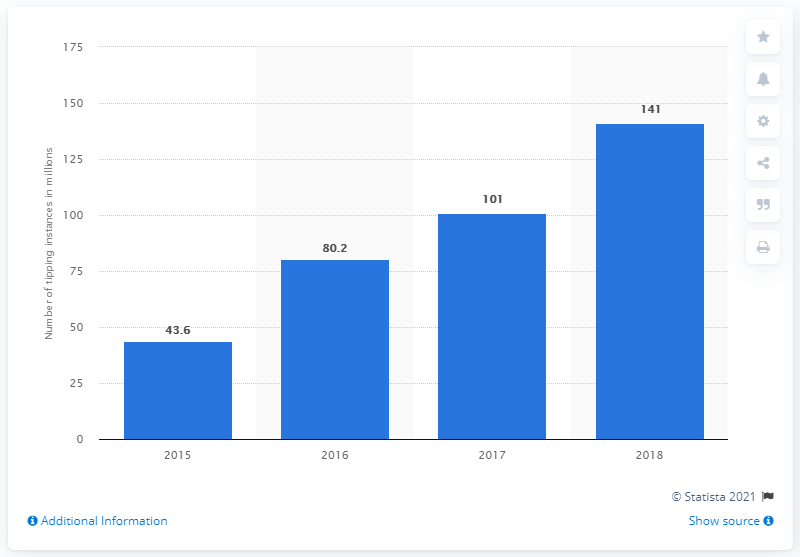Point out several critical features in this image. Between 2015 and 2018, a total of 43.6 tipping instances were recorded. Between 2015 and 2018, a total of 141 tipping instances were recorded on Streamlabs. 